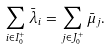<formula> <loc_0><loc_0><loc_500><loc_500>\sum _ { i \in I _ { 0 } ^ { + } } \bar { \lambda } _ { i } = \sum _ { j \in J _ { 0 } ^ { + } } \bar { \mu } _ { j } .</formula> 